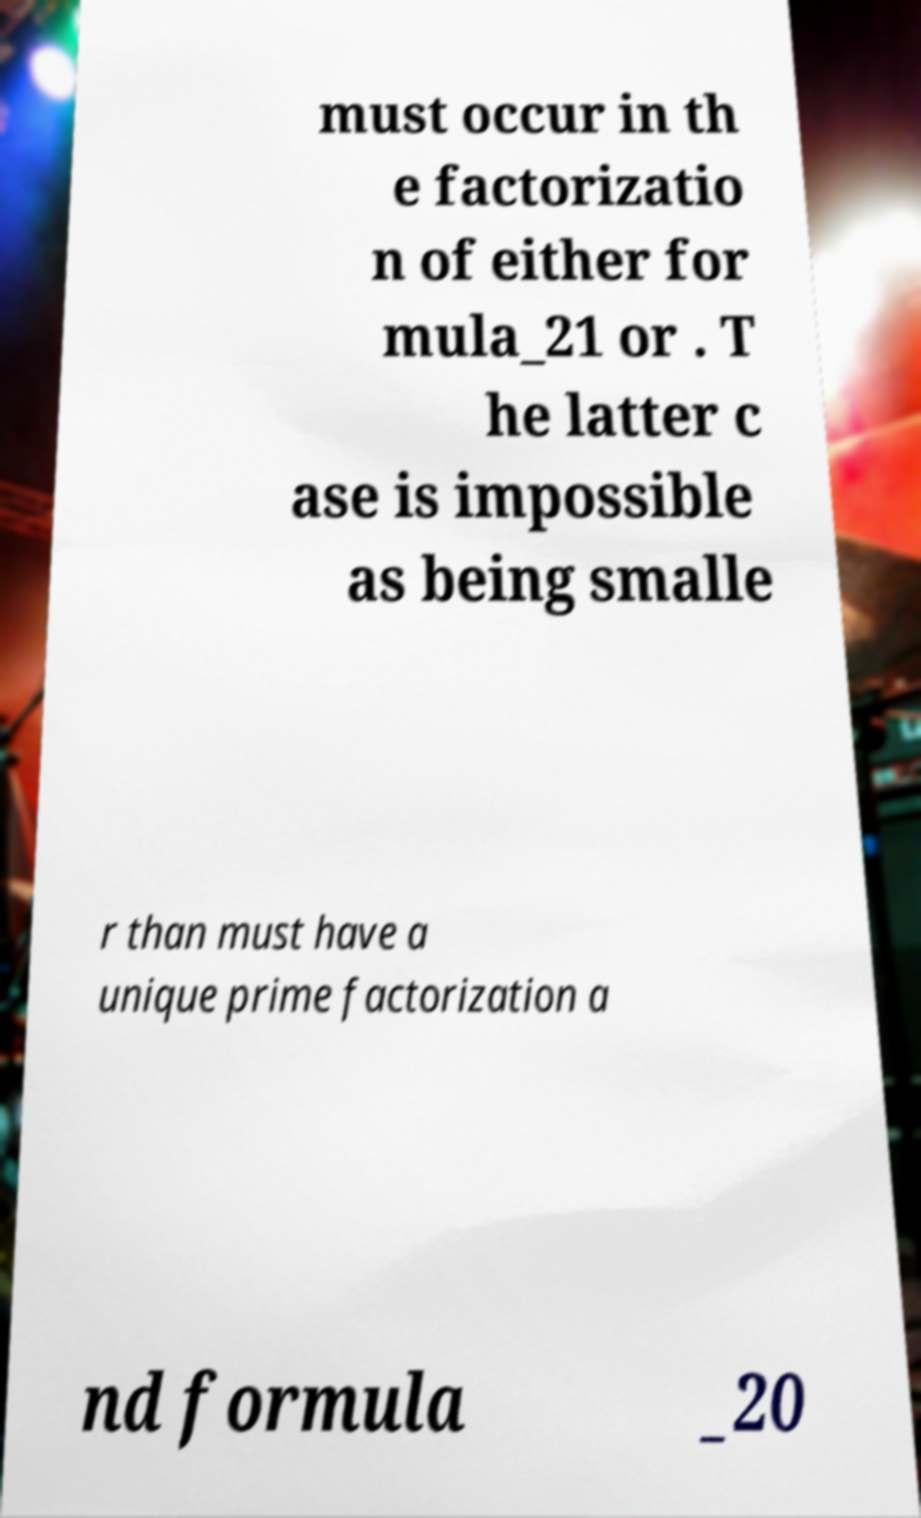Please identify and transcribe the text found in this image. must occur in th e factorizatio n of either for mula_21 or . T he latter c ase is impossible as being smalle r than must have a unique prime factorization a nd formula _20 